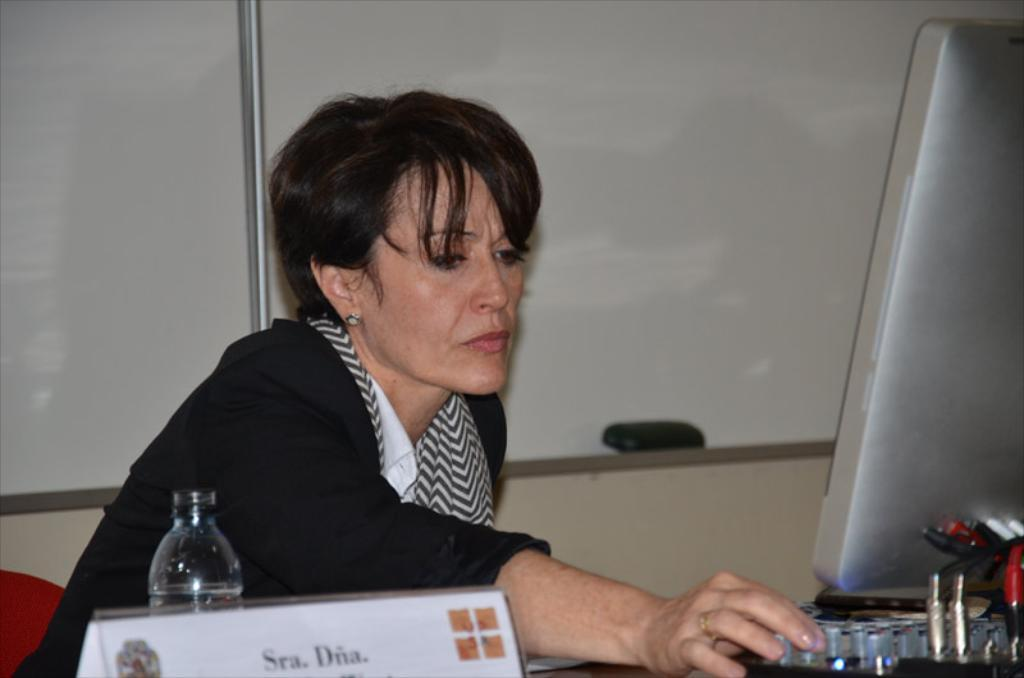What is the lady doing in the image? The lady is sitting on the left side of the image. What is in front of the lady? There is a bottle and a naming board in front of the lady. What is the lady looking at? The lady is looking at a screen in front of her. What can be seen at the top of the image? Boards and a wall are visible at the top of the image. What type of flower is growing on the wall in the image? There are no flowers visible on the wall in the image. Is there any blood visible on the lady in the image? There is no blood visible on the lady or any other part of the image. 